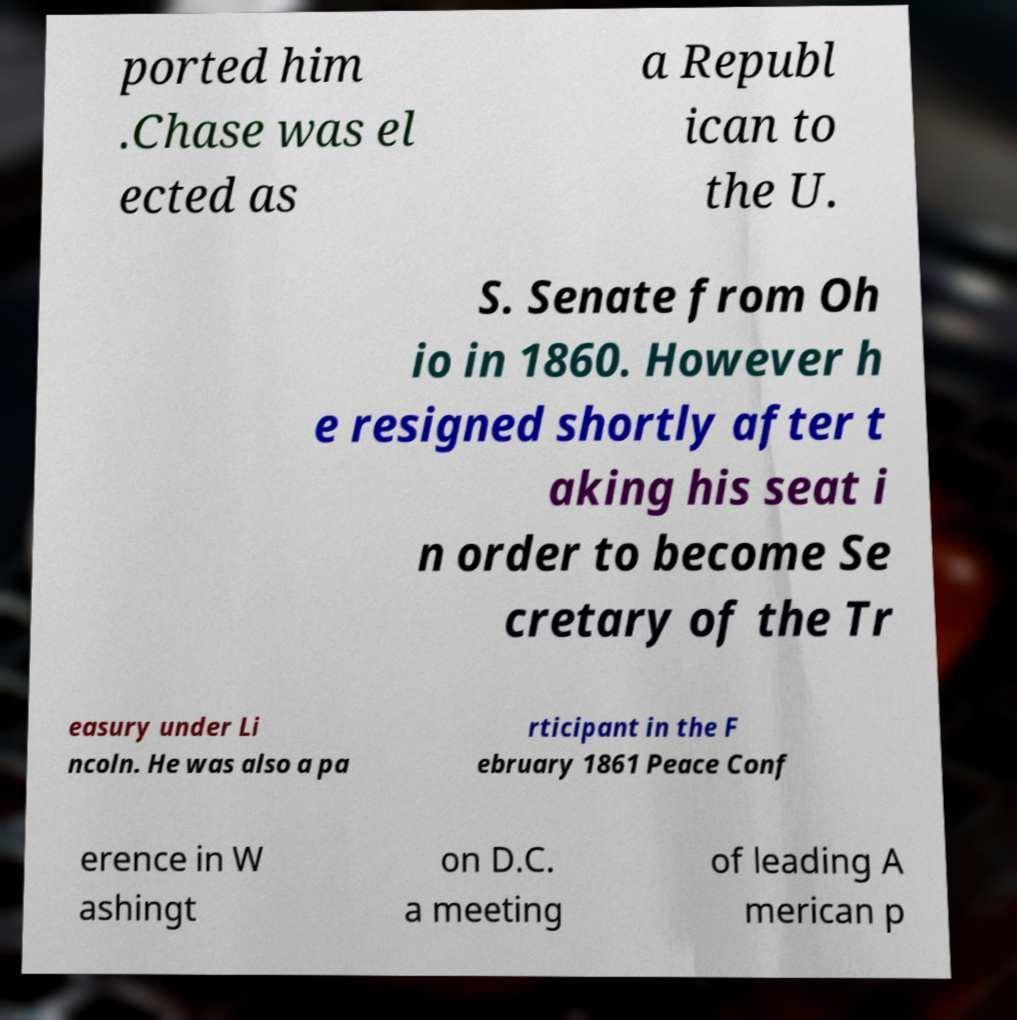Could you extract and type out the text from this image? ported him .Chase was el ected as a Republ ican to the U. S. Senate from Oh io in 1860. However h e resigned shortly after t aking his seat i n order to become Se cretary of the Tr easury under Li ncoln. He was also a pa rticipant in the F ebruary 1861 Peace Conf erence in W ashingt on D.C. a meeting of leading A merican p 